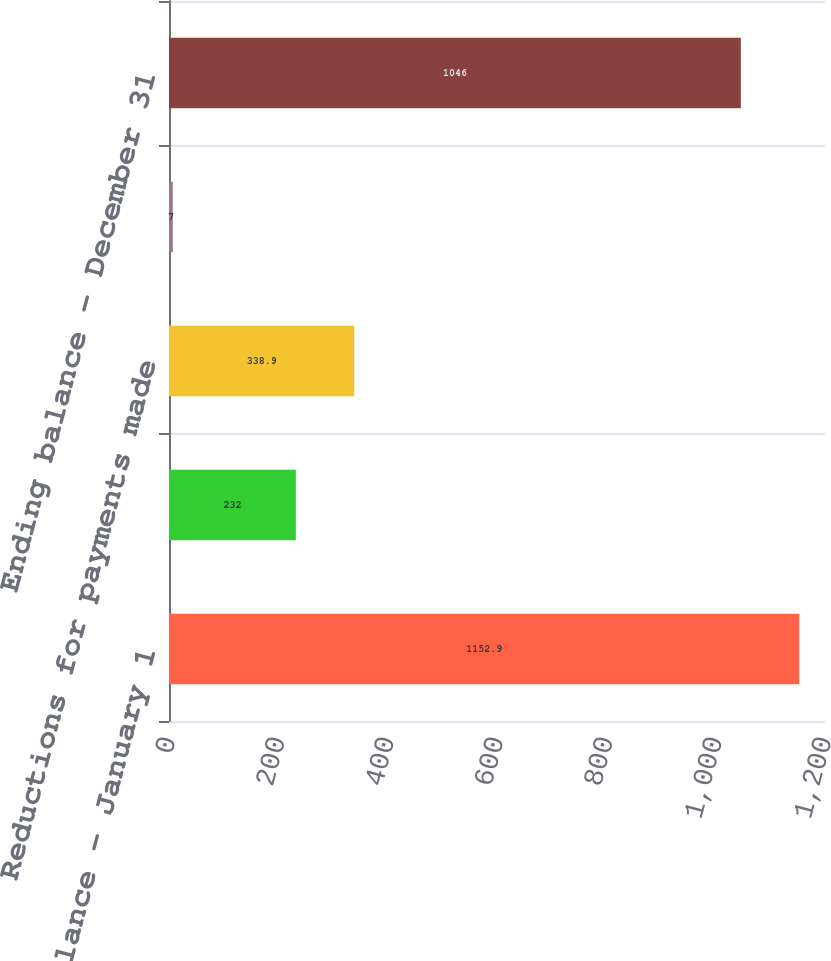<chart> <loc_0><loc_0><loc_500><loc_500><bar_chart><fcel>Beginning balance - January 1<fcel>Additions for current year<fcel>Reductions for payments made<fcel>Changes in estimates<fcel>Ending balance - December 31<nl><fcel>1152.9<fcel>232<fcel>338.9<fcel>7<fcel>1046<nl></chart> 